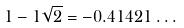<formula> <loc_0><loc_0><loc_500><loc_500>1 - 1 \sqrt { 2 } = - 0 . 4 1 4 2 1 \dots</formula> 